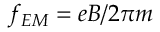<formula> <loc_0><loc_0><loc_500><loc_500>f _ { E M } = e B / 2 \pi m</formula> 